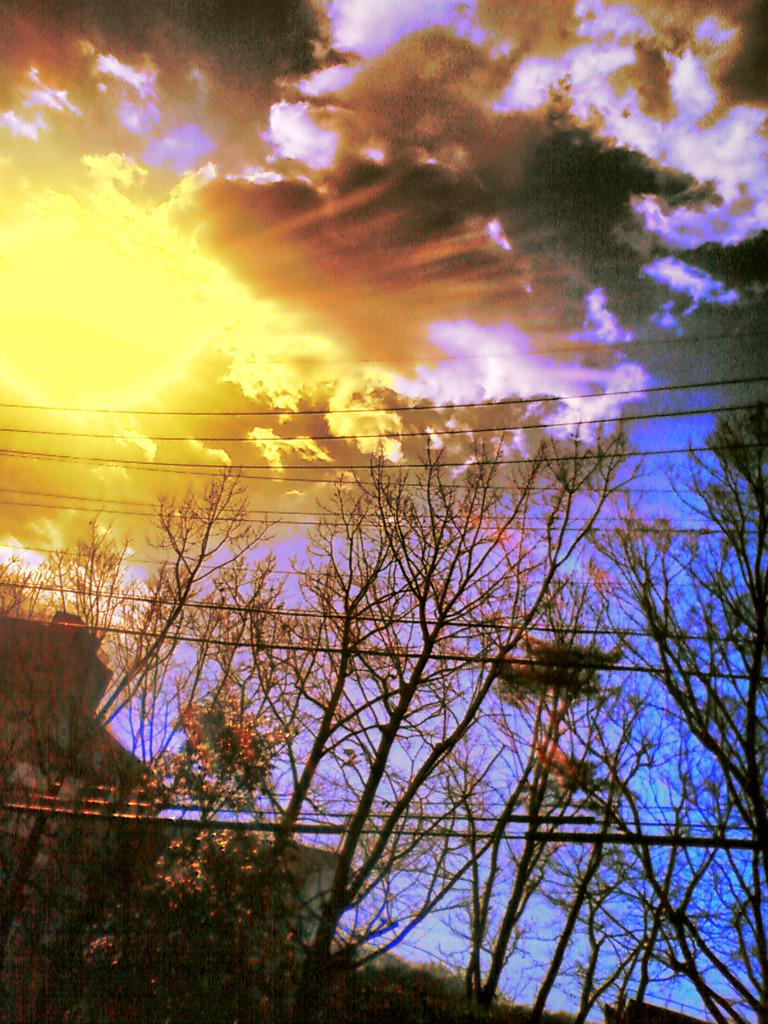What type of natural elements can be seen in the image? There are trees in the image. What man-made structures are visible in the image? There is a building in the image. What can be seen in the sky in the image? The sky is visible at the top of the image, and there are clouds and the sun visible. What else is present in the image besides trees and the building? There are wires in the image. What type of frame is used to hold the office supplies in the image? There is no office or frame present in the image; it features trees, a building, wires, and a sky with clouds and the sun. What color is the can in the image? There is no can present in the image. 